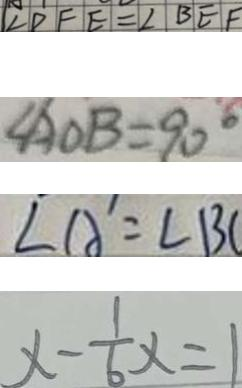Convert formula to latex. <formula><loc_0><loc_0><loc_500><loc_500>\angle D F E = \angle B E F 
 \angle A O B = 9 0 ^ { \circ } 
 \angle A ^ { \prime } = \angle B C 
 x - \frac { 1 } { 6 } x = 1</formula> 